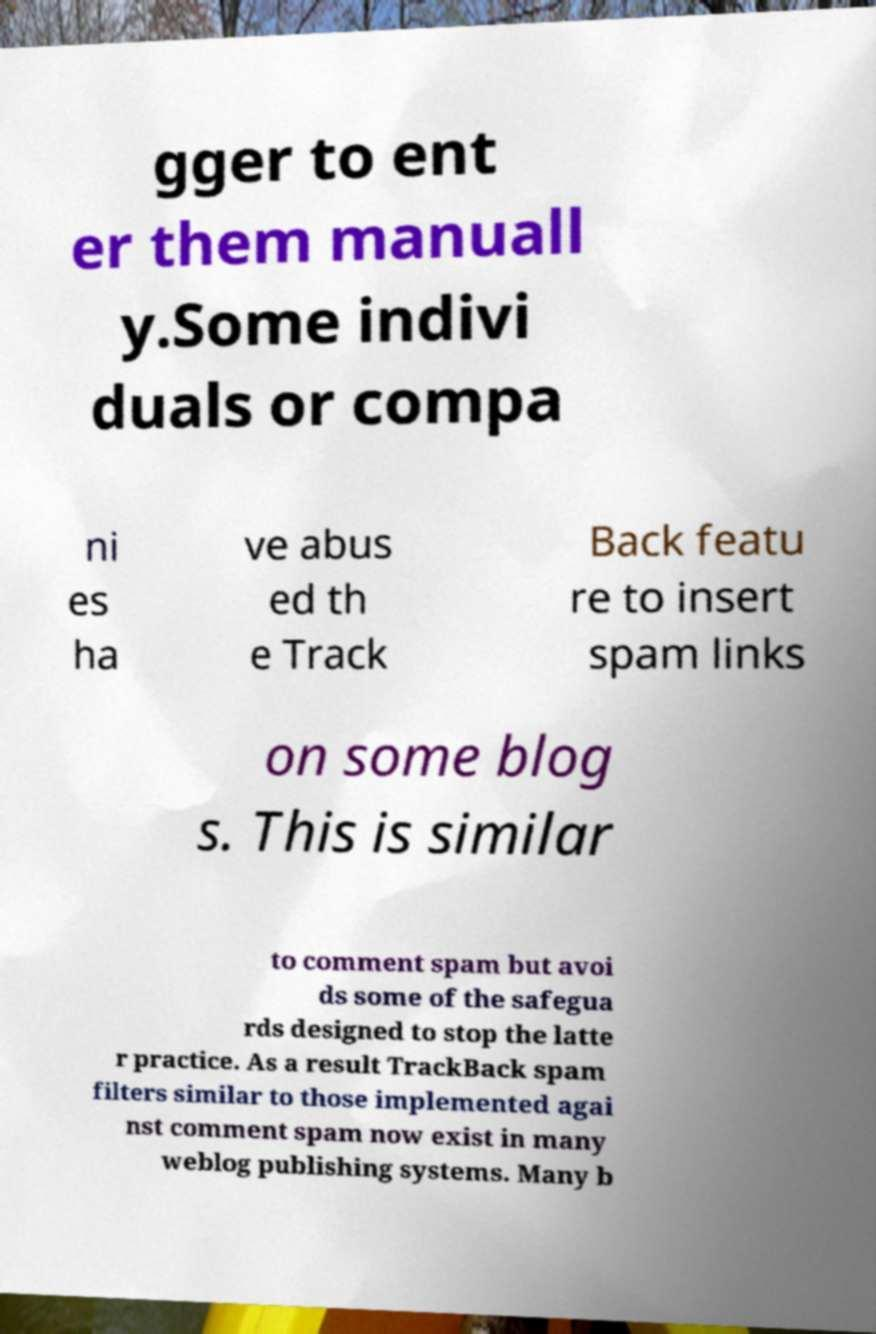Can you accurately transcribe the text from the provided image for me? gger to ent er them manuall y.Some indivi duals or compa ni es ha ve abus ed th e Track Back featu re to insert spam links on some blog s. This is similar to comment spam but avoi ds some of the safegua rds designed to stop the latte r practice. As a result TrackBack spam filters similar to those implemented agai nst comment spam now exist in many weblog publishing systems. Many b 